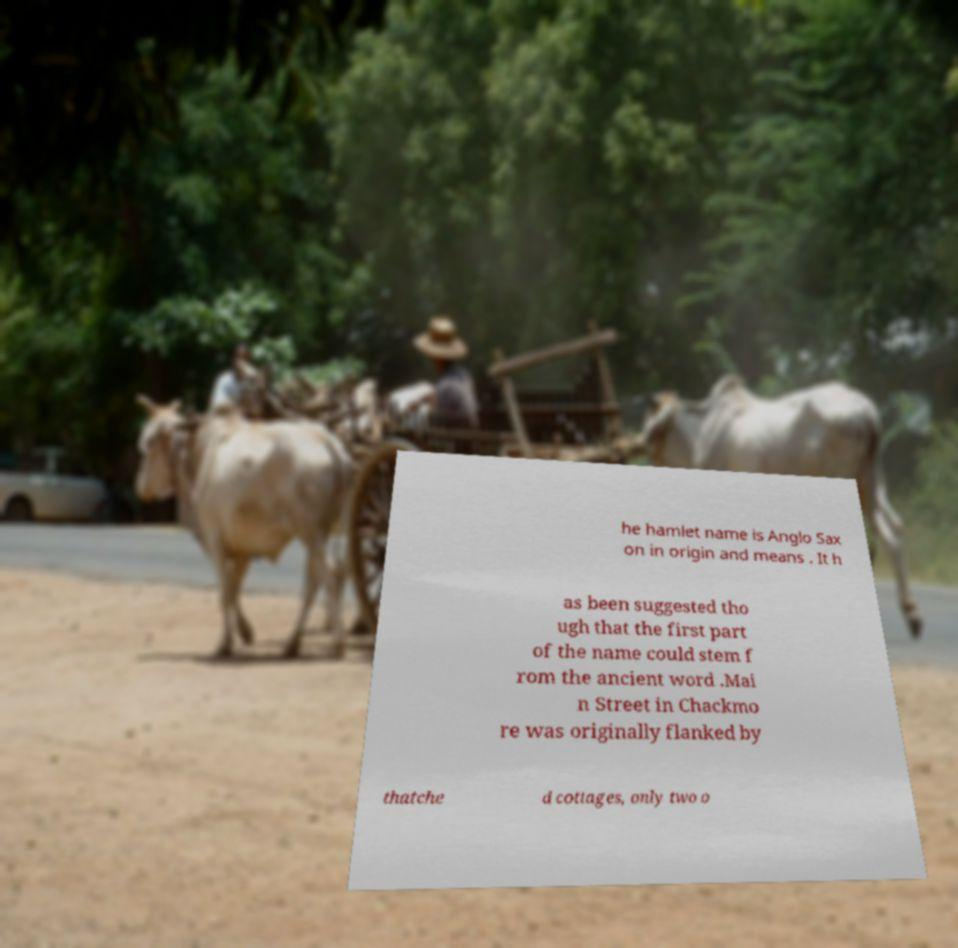For documentation purposes, I need the text within this image transcribed. Could you provide that? he hamlet name is Anglo Sax on in origin and means . It h as been suggested tho ugh that the first part of the name could stem f rom the ancient word .Mai n Street in Chackmo re was originally flanked by thatche d cottages, only two o 